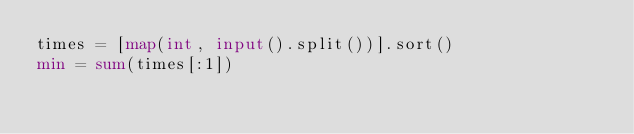<code> <loc_0><loc_0><loc_500><loc_500><_Python_>times = [map(int, input().split())].sort()
min = sum(times[:1])
</code> 